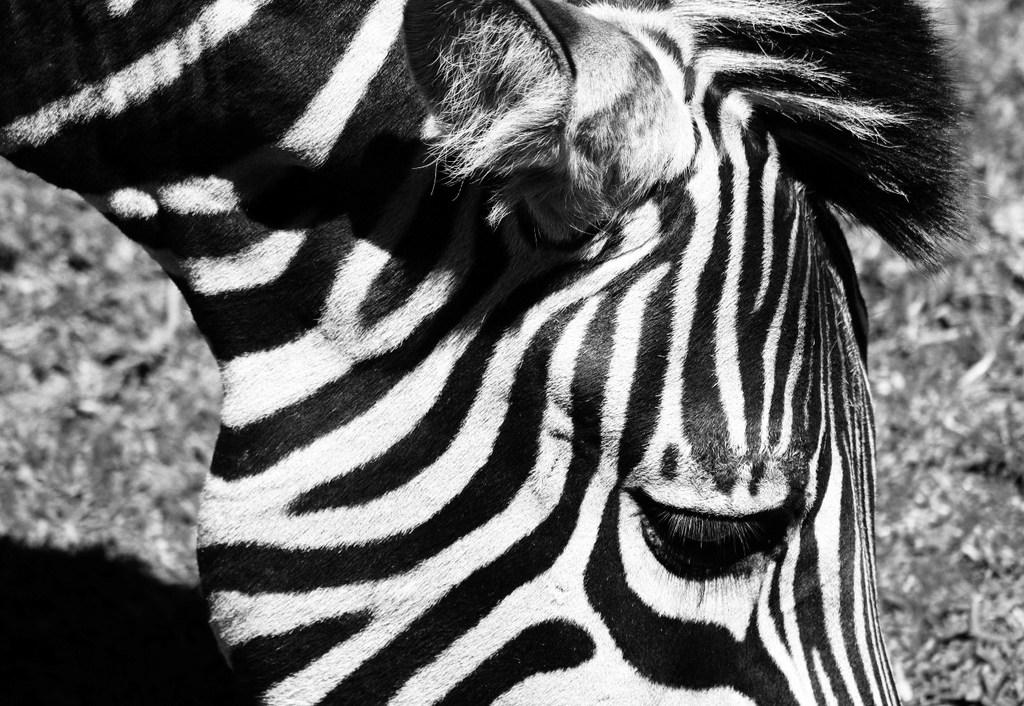What animal is present in the image? There is a zebra in the image. What is the color scheme of the image? The image appears to be black and white. What type of surface is visible at the bottom of the image? There is ground visible at the bottom of the image. Can you see any matches being lit in the image? There are no matches or any indication of fire in the image. What type of weather condition is present in the image? The provided facts do not mention any weather conditions, so we cannot determine if there is fog or any other weather condition in the image. 